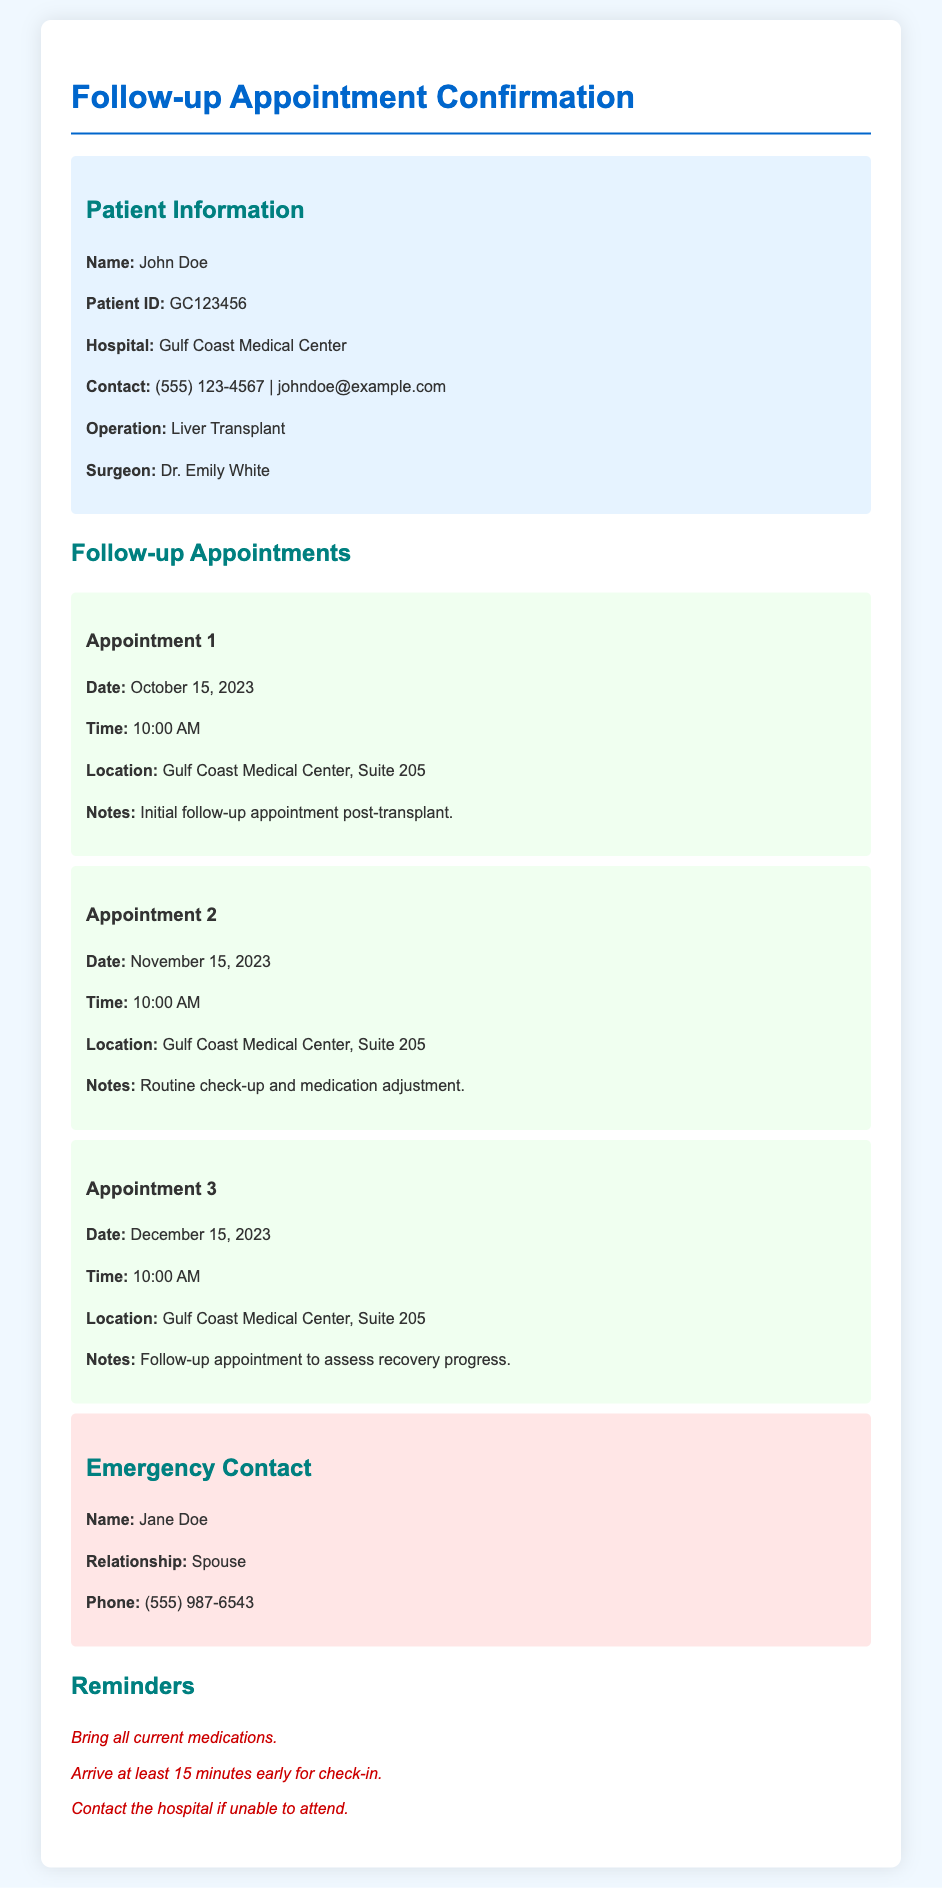What is the patient's name? The patient's name is stated in the patient information section of the document.
Answer: John Doe What is the date of the first follow-up appointment? The date of the first appointment is detailed under the follow-up appointments section.
Answer: October 15, 2023 Who is the surgeon? The surgeon's name is listed in the patient information section of the document.
Answer: Dr. Emily White How many follow-up appointments are scheduled? The document lists multiple follow-up appointments, each distinctly identified.
Answer: 3 What is the location for all follow-up appointments? The location of the appointments is provided in each appointment section, indicating where they will occur.
Answer: Gulf Coast Medical Center, Suite 205 What should the patient bring to the appointments? The reminders section highlights what the patient should prepare for their appointments.
Answer: All current medications What is the time of the second appointment? The time of the second appointment is outlined in its respective section.
Answer: 10:00 AM What relationship is the emergency contact to the patient? The relationship of the emergency contact is listed in the emergency contact section.
Answer: Spouse What is the emergency contact's name? The name of the emergency contact is provided in the emergency contact section.
Answer: Jane Doe 